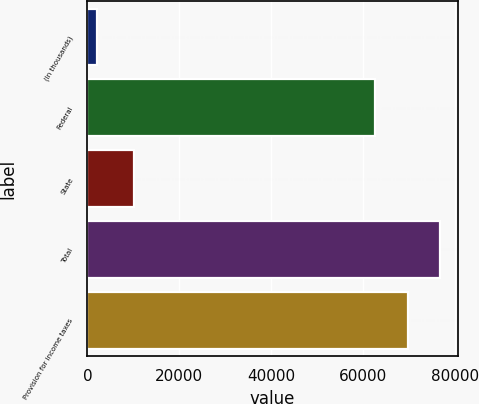Convert chart to OTSL. <chart><loc_0><loc_0><loc_500><loc_500><bar_chart><fcel>(In thousands)<fcel>Federal<fcel>State<fcel>Total<fcel>Provision for income taxes<nl><fcel>2005<fcel>62662<fcel>10117<fcel>76816.8<fcel>69739.4<nl></chart> 